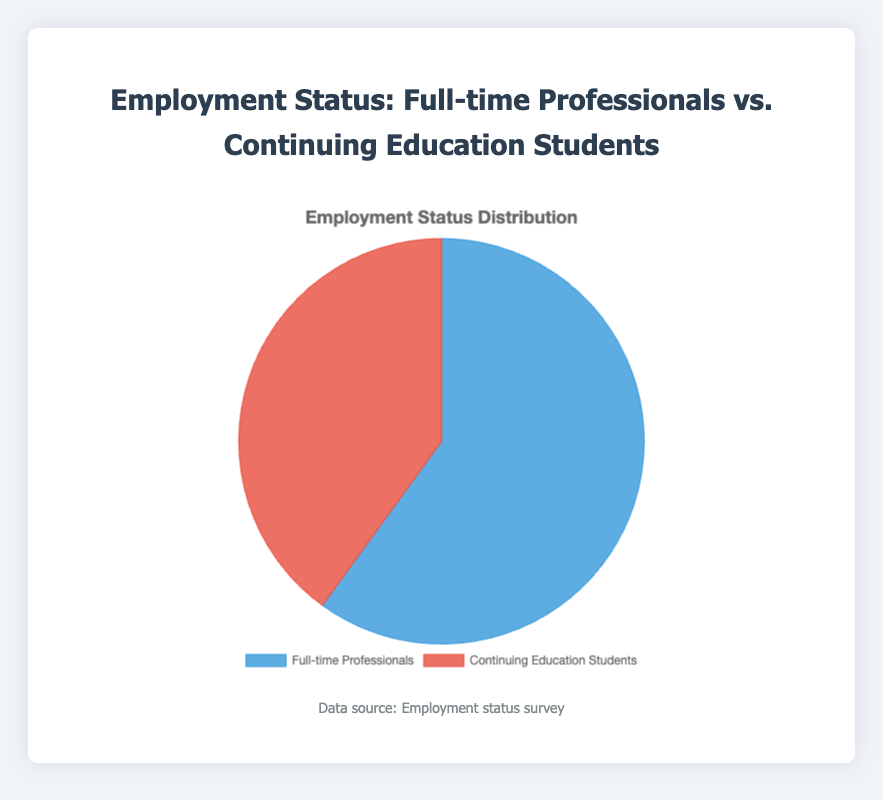Do Full-time Professionals or Continuing Education Students have the higher percentage in the pie chart? The pie chart shows two groups: Full-time Professionals and Continuing Education Students. By visually comparing the sections, we can see that Full-time Professionals have the larger section, labeled as 60%, compared to Continuing Education Students, labeled as 40%.
Answer: Full-time Professionals What is the difference in percentage between Full-time Professionals and Continuing Education Students? According to the pie chart, Full-time Professionals make up 60% of the total, while Continuing Education Students make up 40%. The difference between the two percentages is calculated as 60% - 40%.
Answer: 20% What fraction of the total does the Continuing Education Students make up? The pie chart indicates that Continuing Education Students account for 40% of the total. This percentage can be converted to a fraction by dividing 40 by 100, resulting in 40/100 or 2/5.
Answer: 2/5 Which group has more representation, and by what fractional amount? From the pie chart, Full-time Professionals have 60% and Continuing Education Students have 40%. The difference in their representation is 60% - 40% which equals 20%. This percentage difference translates to a fraction by dividing 20 by 100, resulting in 20/100 or 1/5.
Answer: Full-time Professionals by 1/5 How many times larger is the percentage of Full-time Professionals compared to Continuing Education Students? The pie chart shows Full-time Professionals at 60% and Continuing Education Students at 40%. To determine how many times larger the percentage of Full-time Professionals is, divide 60% by 40%, which equals 1.5.
Answer: 1.5 times If the total sample size is 200 people, how many people are Full-time Professionals? The pie chart indicates that 60% of the sample are Full-time Professionals. To find the number of Full-time Professionals out of 200 people, multiply 200 by 0.60, resulting in 120.
Answer: 120 What color represents the Continuing Education Students in the pie chart? By observing the chart, the red segment illustrates Continuing Education Students. To confirm, the pie chart has two color-coded sections: blue for Full-time Professionals and red for Continuing Education Students.
Answer: Red 